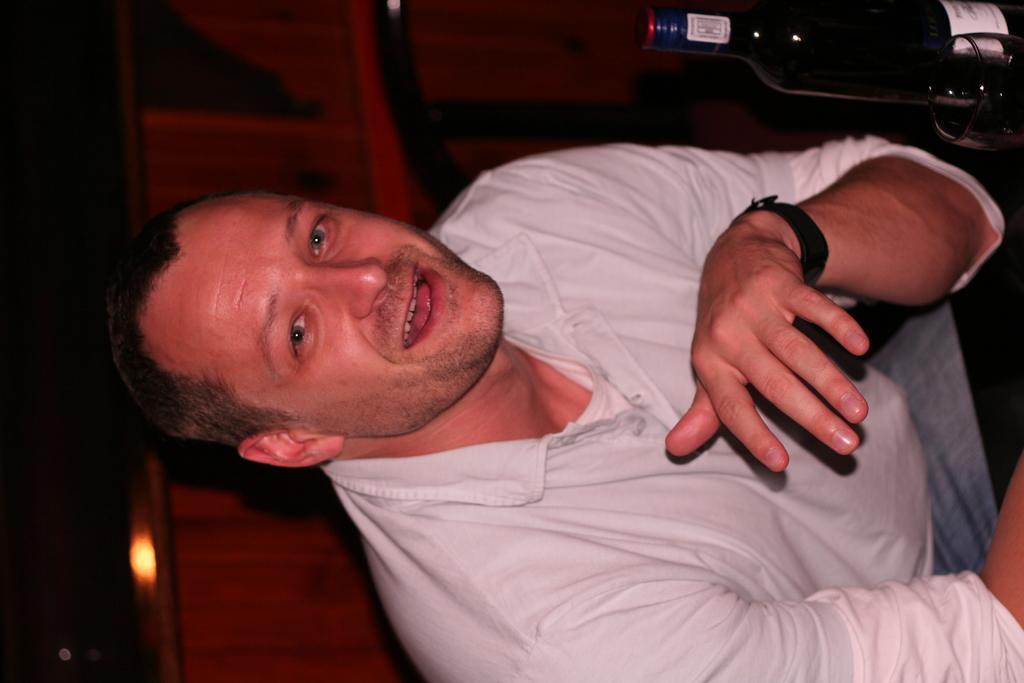How would you summarize this image in a sentence or two? This image consists of a man wearing a white T-shirt. At the top, we can see a bottle. In the background, we can see a wooden block. 